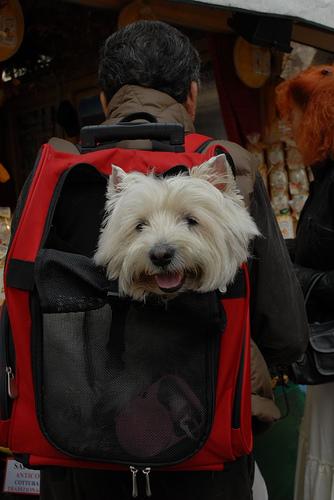What breed is the dog?
Be succinct. Shih tzu. Is there a cat in the backpack?
Keep it brief. No. Does the boy have a leash on the dog?
Keep it brief. No. What animal is this?
Keep it brief. Dog. Is this dog struggling to be set free?
Keep it brief. No. What color is the backpack?
Quick response, please. Red and black. 